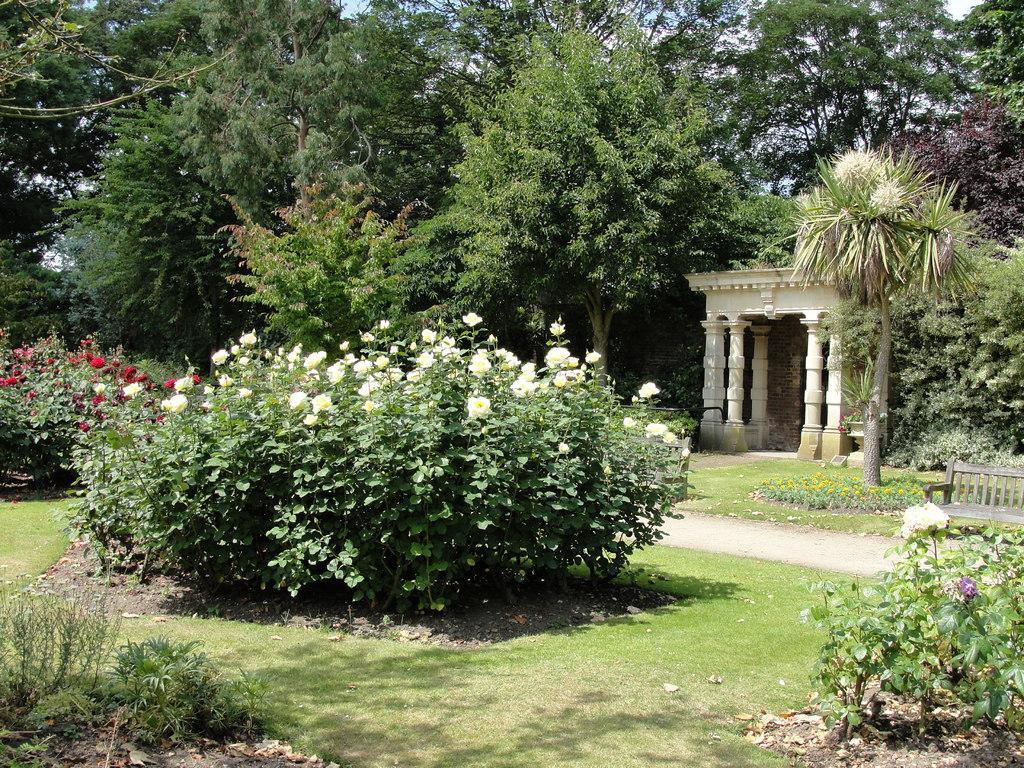Describe this image in one or two sentences. This image consists of many plants and trees. In the front, we can see the flowers in red and white color. On the right, there is an arch and a bench. At the bottom, there is green grass. 